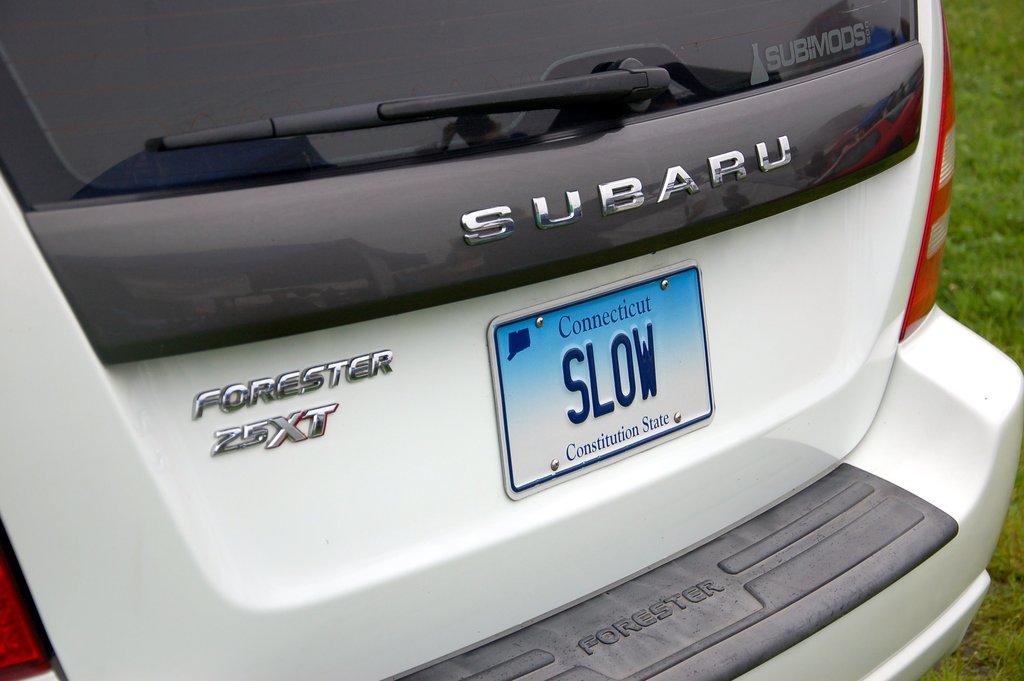What does the vanity plate say?
Offer a very short reply. Slow. 